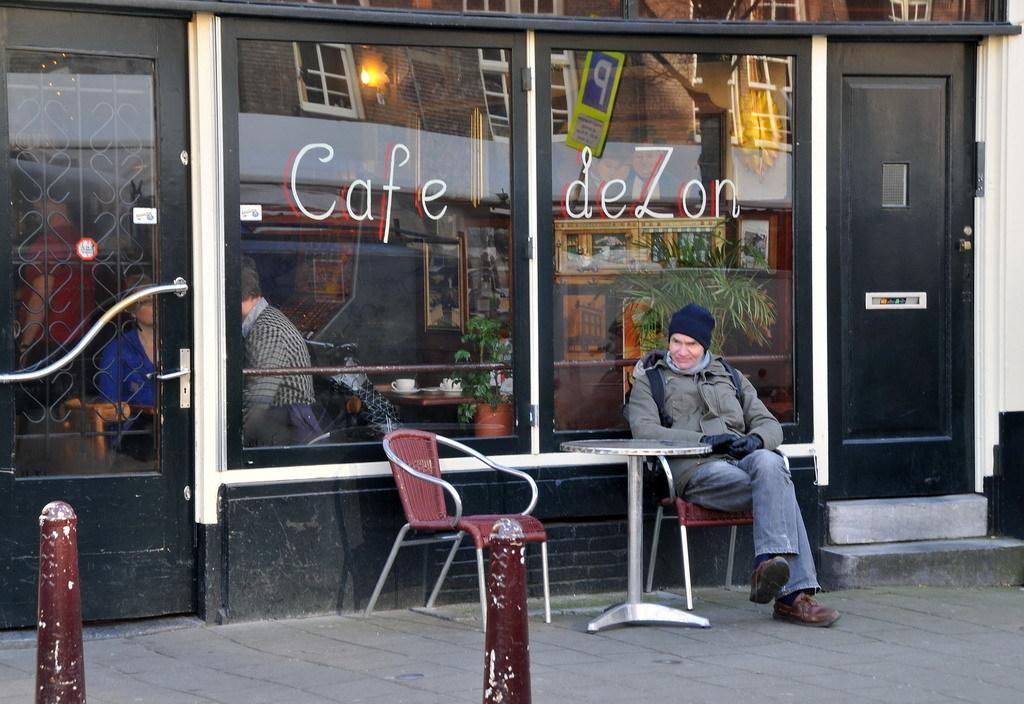In one or two sentences, can you explain what this image depicts? In this picture a guy is sitting on the table in front of cafe desert. In the background we observe a cafe and through glass windows and doors we can observe people sitting inside the cafe and food eatables are on top of the table. There is also a black door to the right side of the image. 